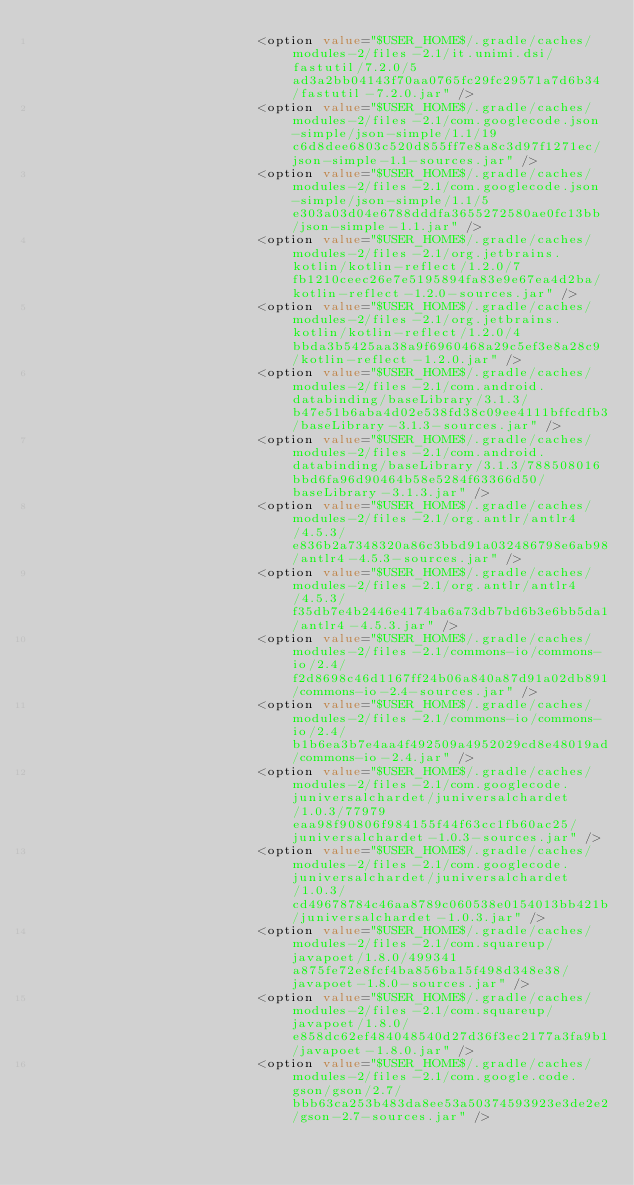Convert code to text. <code><loc_0><loc_0><loc_500><loc_500><_XML_>                            <option value="$USER_HOME$/.gradle/caches/modules-2/files-2.1/it.unimi.dsi/fastutil/7.2.0/5ad3a2bb04143f70aa0765fc29fc29571a7d6b34/fastutil-7.2.0.jar" />
                            <option value="$USER_HOME$/.gradle/caches/modules-2/files-2.1/com.googlecode.json-simple/json-simple/1.1/19c6d8dee6803c520d855ff7e8a8c3d97f1271ec/json-simple-1.1-sources.jar" />
                            <option value="$USER_HOME$/.gradle/caches/modules-2/files-2.1/com.googlecode.json-simple/json-simple/1.1/5e303a03d04e6788dddfa3655272580ae0fc13bb/json-simple-1.1.jar" />
                            <option value="$USER_HOME$/.gradle/caches/modules-2/files-2.1/org.jetbrains.kotlin/kotlin-reflect/1.2.0/7fb1210ceec26e7e5195894fa83e9e67ea4d2ba/kotlin-reflect-1.2.0-sources.jar" />
                            <option value="$USER_HOME$/.gradle/caches/modules-2/files-2.1/org.jetbrains.kotlin/kotlin-reflect/1.2.0/4bbda3b5425aa38a9f6960468a29c5ef3e8a28c9/kotlin-reflect-1.2.0.jar" />
                            <option value="$USER_HOME$/.gradle/caches/modules-2/files-2.1/com.android.databinding/baseLibrary/3.1.3/b47e51b6aba4d02e538fd38c09ee4111bffcdfb3/baseLibrary-3.1.3-sources.jar" />
                            <option value="$USER_HOME$/.gradle/caches/modules-2/files-2.1/com.android.databinding/baseLibrary/3.1.3/788508016bbd6fa96d90464b58e5284f63366d50/baseLibrary-3.1.3.jar" />
                            <option value="$USER_HOME$/.gradle/caches/modules-2/files-2.1/org.antlr/antlr4/4.5.3/e836b2a7348320a86c3bbd91a032486798e6ab98/antlr4-4.5.3-sources.jar" />
                            <option value="$USER_HOME$/.gradle/caches/modules-2/files-2.1/org.antlr/antlr4/4.5.3/f35db7e4b2446e4174ba6a73db7bd6b3e6bb5da1/antlr4-4.5.3.jar" />
                            <option value="$USER_HOME$/.gradle/caches/modules-2/files-2.1/commons-io/commons-io/2.4/f2d8698c46d1167ff24b06a840a87d91a02db891/commons-io-2.4-sources.jar" />
                            <option value="$USER_HOME$/.gradle/caches/modules-2/files-2.1/commons-io/commons-io/2.4/b1b6ea3b7e4aa4f492509a4952029cd8e48019ad/commons-io-2.4.jar" />
                            <option value="$USER_HOME$/.gradle/caches/modules-2/files-2.1/com.googlecode.juniversalchardet/juniversalchardet/1.0.3/77979eaa98f90806f984155f44f63cc1fb60ac25/juniversalchardet-1.0.3-sources.jar" />
                            <option value="$USER_HOME$/.gradle/caches/modules-2/files-2.1/com.googlecode.juniversalchardet/juniversalchardet/1.0.3/cd49678784c46aa8789c060538e0154013bb421b/juniversalchardet-1.0.3.jar" />
                            <option value="$USER_HOME$/.gradle/caches/modules-2/files-2.1/com.squareup/javapoet/1.8.0/499341a875fe72e8fcf4ba856ba15f498d348e38/javapoet-1.8.0-sources.jar" />
                            <option value="$USER_HOME$/.gradle/caches/modules-2/files-2.1/com.squareup/javapoet/1.8.0/e858dc62ef484048540d27d36f3ec2177a3fa9b1/javapoet-1.8.0.jar" />
                            <option value="$USER_HOME$/.gradle/caches/modules-2/files-2.1/com.google.code.gson/gson/2.7/bbb63ca253b483da8ee53a50374593923e3de2e2/gson-2.7-sources.jar" /></code> 